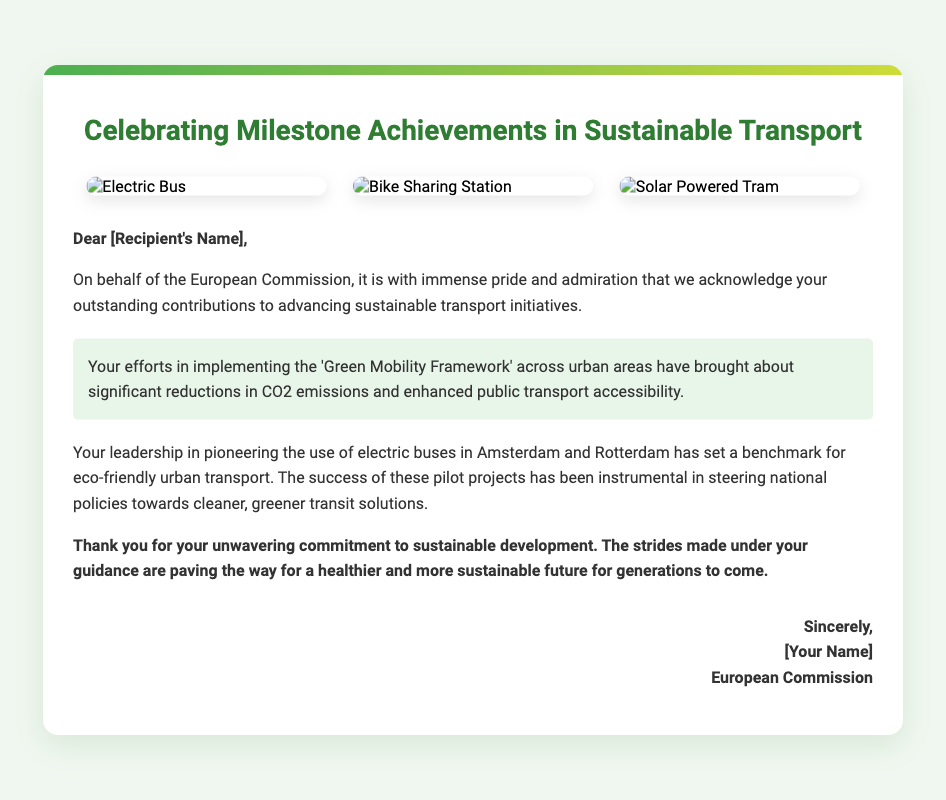what is the title of the card? The title is prominently displayed at the top of the card, acknowledging the achievements in sustainable transport.
Answer: Celebrating Milestone Achievements in Sustainable Transport who is the greeting card addressed to? The card starts with a direct greeting to the recipient, indicating a personal touch.
Answer: [Recipient's Name] which initiative is highlighted in the card? The card mentions a specific initiative that the recipient has worked on to promote sustainable transport.
Answer: Green Mobility Framework how many images are included in the image container? The image container features multiple images illustrating eco-friendly transport options provided in the card.
Answer: 3 what cities are mentioned for the use of electric buses? The content refers to specific cities where electric buses have been implemented as part of the recipient's achievements.
Answer: Amsterdam and Rotterdam what is the color scheme of the card? The card employs a specific color scheme to emphasize its theme of sustainability and celebration.
Answer: Green accents what is the closing expression used in the card? At the end of the card, a formal sign-off is provided to conclude the message.
Answer: Sincerely which organization is represented in the card? The card clearly indicates which organization is acknowledging the recipient's contributions to sustainable transport.
Answer: European Commission 